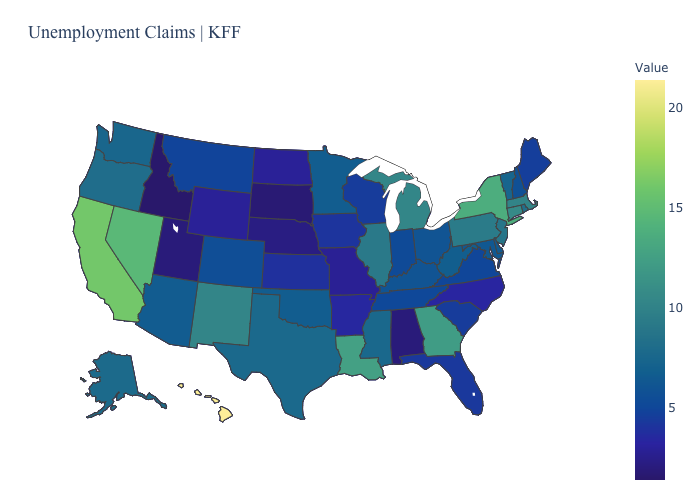Which states have the lowest value in the MidWest?
Keep it brief. South Dakota. Does Oregon have a lower value than Alabama?
Keep it brief. No. Which states have the lowest value in the USA?
Concise answer only. Idaho. Does Minnesota have the lowest value in the MidWest?
Concise answer only. No. Does Idaho have the lowest value in the USA?
Be succinct. Yes. Does Connecticut have the lowest value in the USA?
Answer briefly. No. 